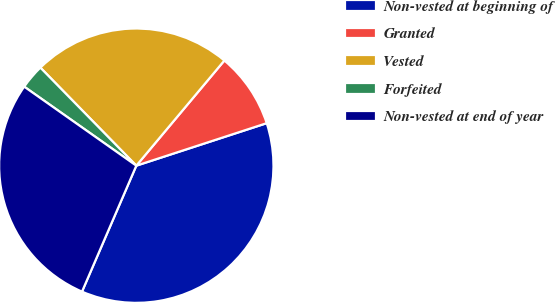Convert chart to OTSL. <chart><loc_0><loc_0><loc_500><loc_500><pie_chart><fcel>Non-vested at beginning of<fcel>Granted<fcel>Vested<fcel>Forfeited<fcel>Non-vested at end of year<nl><fcel>36.49%<fcel>8.89%<fcel>23.42%<fcel>2.9%<fcel>28.29%<nl></chart> 